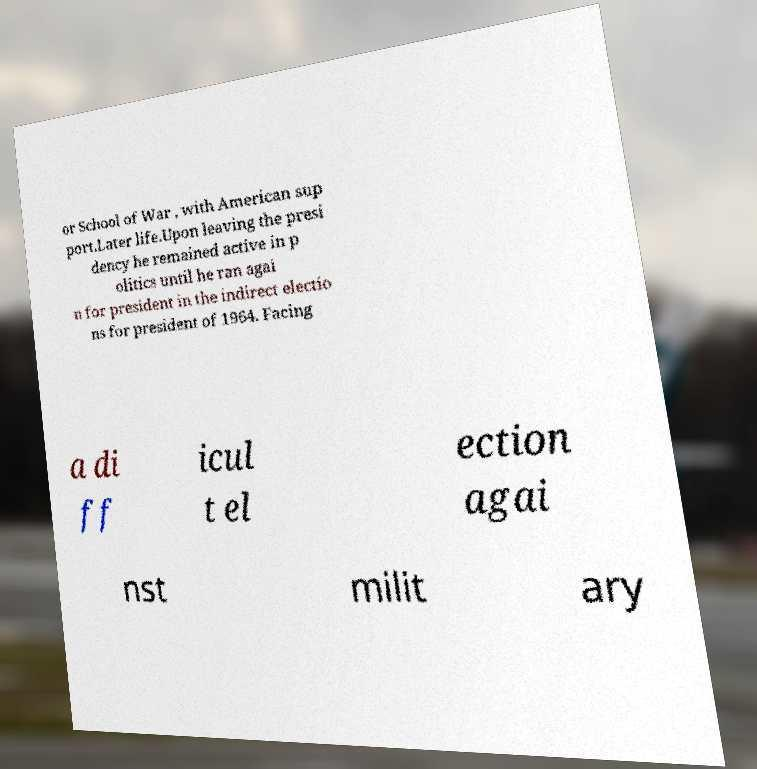Could you extract and type out the text from this image? or School of War , with American sup port.Later life.Upon leaving the presi dency he remained active in p olitics until he ran agai n for president in the indirect electio ns for president of 1964. Facing a di ff icul t el ection agai nst milit ary 